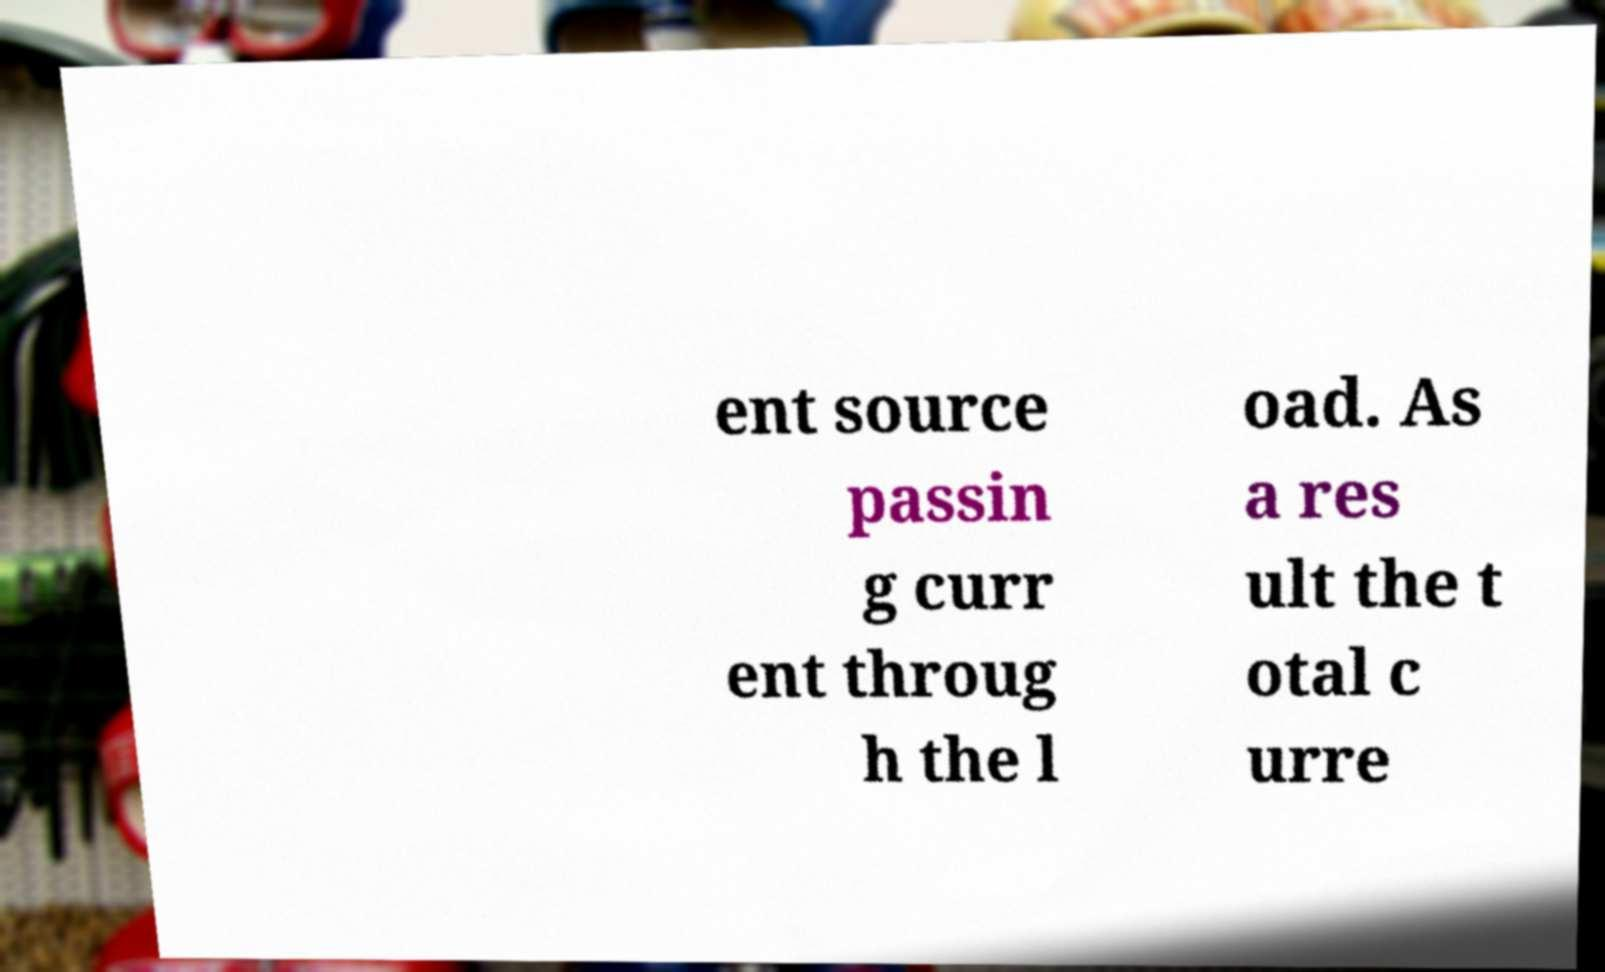Please identify and transcribe the text found in this image. ent source passin g curr ent throug h the l oad. As a res ult the t otal c urre 